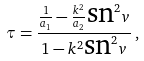<formula> <loc_0><loc_0><loc_500><loc_500>\tau = \frac { \frac { 1 } { a _ { 1 } } - \frac { k ^ { 2 } } { a _ { 2 } } \text {sn} ^ { 2 } v } { 1 - k ^ { 2 } \text {sn} ^ { 2 } v } \, ,</formula> 